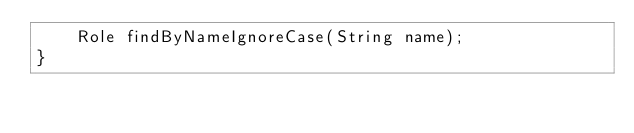Convert code to text. <code><loc_0><loc_0><loc_500><loc_500><_Java_>    Role findByNameIgnoreCase(String name);
}
</code> 